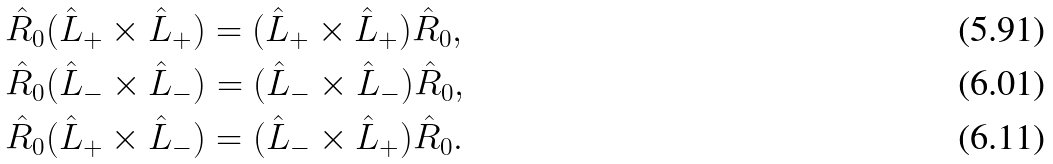<formula> <loc_0><loc_0><loc_500><loc_500>& \hat { R } _ { 0 } ( \hat { L } _ { + } \times \hat { L } _ { + } ) = ( \hat { L } _ { + } \times \hat { L } _ { + } ) \hat { R } _ { 0 } , \\ & \hat { R } _ { 0 } ( \hat { L } _ { - } \times \hat { L } _ { - } ) = ( \hat { L } _ { - } \times \hat { L } _ { - } ) \hat { R } _ { 0 } , \\ & \hat { R } _ { 0 } ( \hat { L } _ { + } \times \hat { L } _ { - } ) = ( \hat { L } _ { - } \times \hat { L } _ { + } ) \hat { R } _ { 0 } .</formula> 